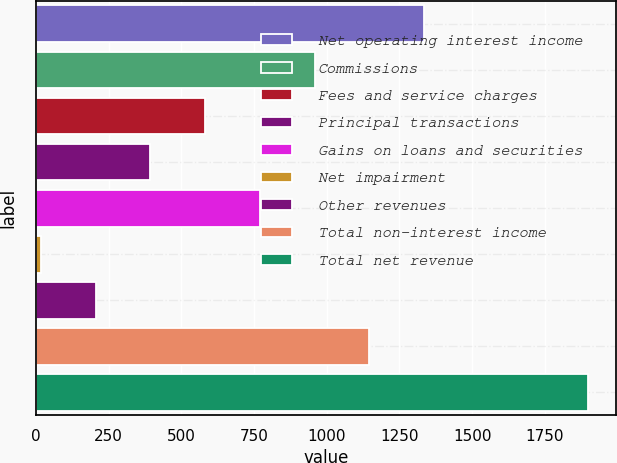Convert chart to OTSL. <chart><loc_0><loc_0><loc_500><loc_500><bar_chart><fcel>Net operating interest income<fcel>Commissions<fcel>Fees and service charges<fcel>Principal transactions<fcel>Gains on loans and securities<fcel>Net impairment<fcel>Other revenues<fcel>Total non-interest income<fcel>Total net revenue<nl><fcel>1334.72<fcel>958.2<fcel>581.68<fcel>393.42<fcel>769.94<fcel>16.9<fcel>205.16<fcel>1146.46<fcel>1899.5<nl></chart> 